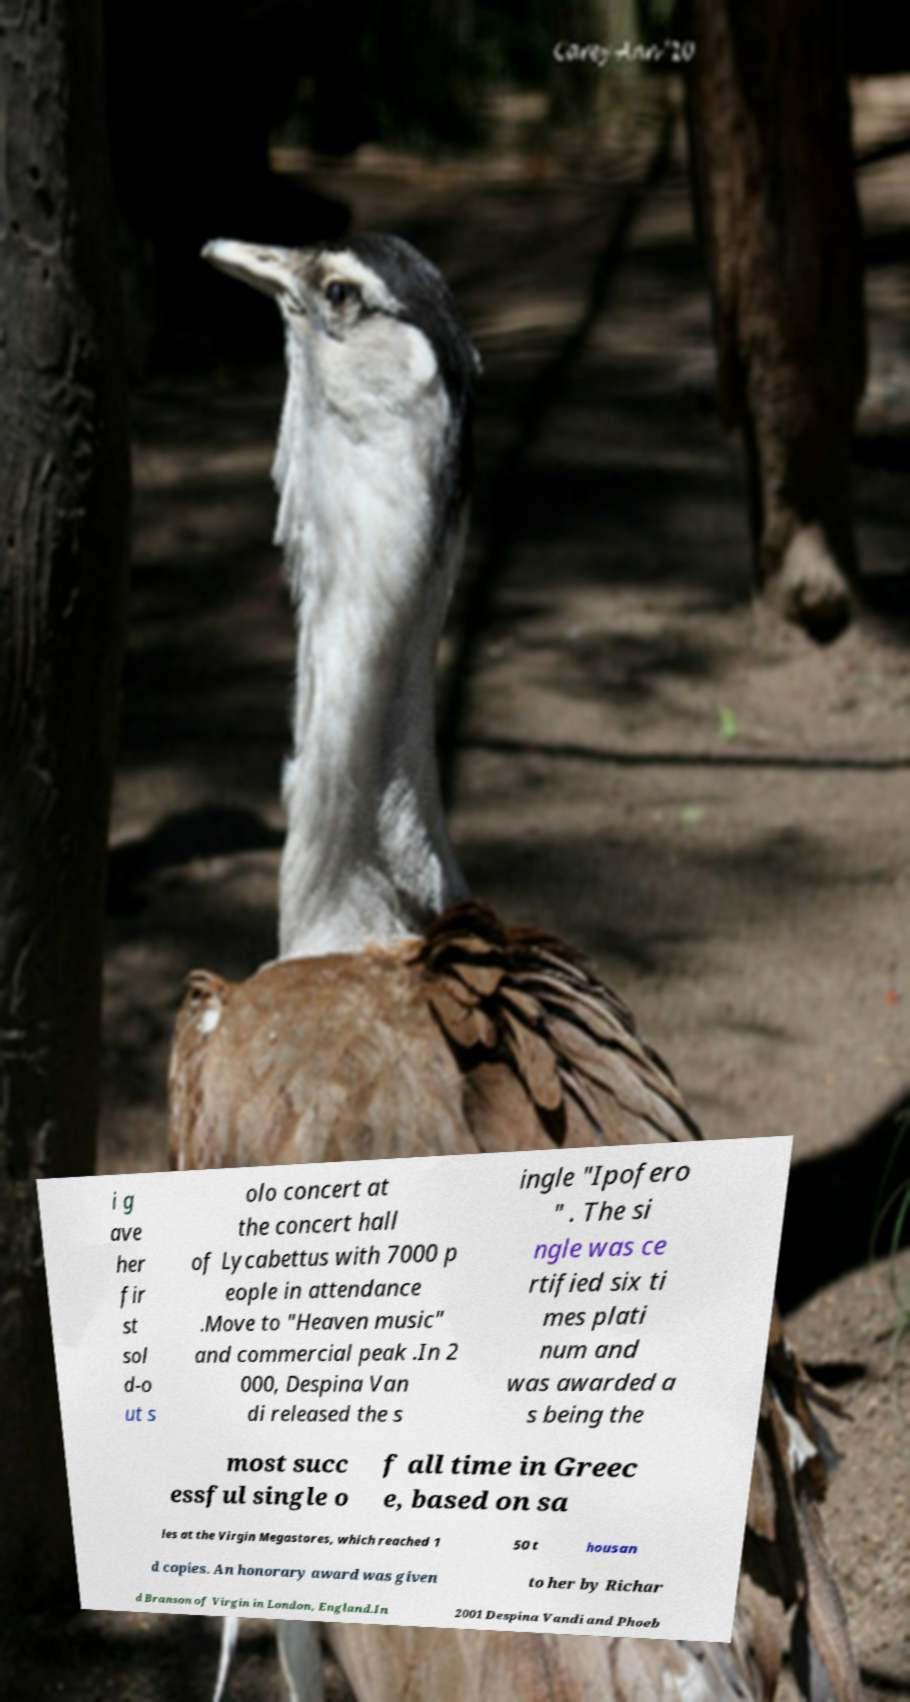Could you assist in decoding the text presented in this image and type it out clearly? i g ave her fir st sol d-o ut s olo concert at the concert hall of Lycabettus with 7000 p eople in attendance .Move to "Heaven music" and commercial peak .In 2 000, Despina Van di released the s ingle "Ipofero " . The si ngle was ce rtified six ti mes plati num and was awarded a s being the most succ essful single o f all time in Greec e, based on sa les at the Virgin Megastores, which reached 1 50 t housan d copies. An honorary award was given to her by Richar d Branson of Virgin in London, England.In 2001 Despina Vandi and Phoeb 